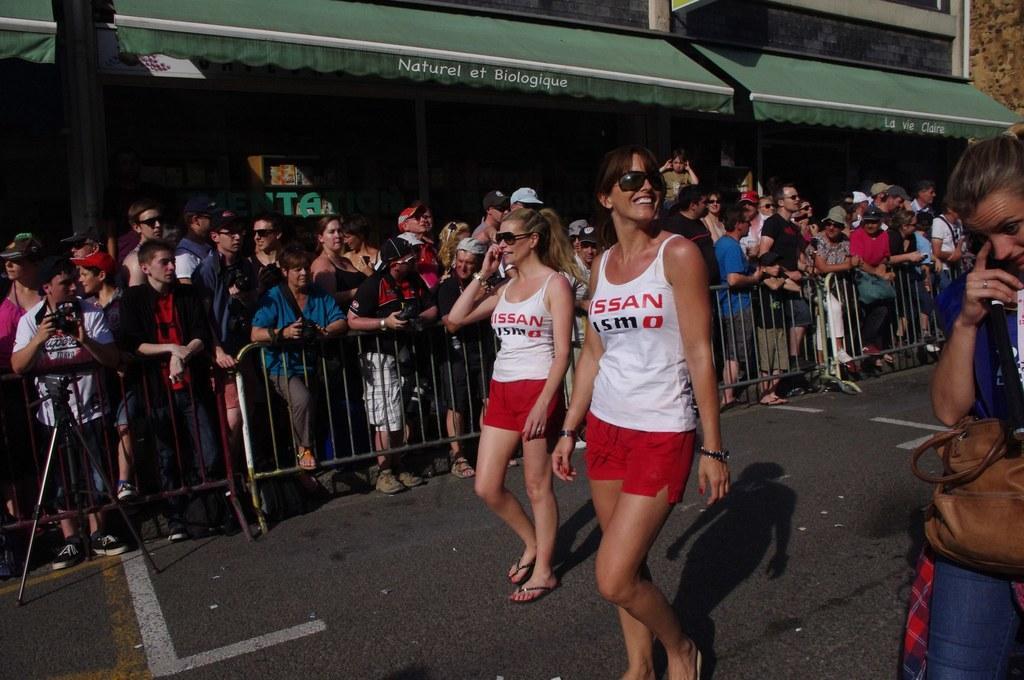Please provide a concise description of this image. This is the picture of a road. In this image there are two persons with white t-shirt walking on the road and smiling. At the back there are group of people standing behind the railing. On the left side of the image there is a person with white t-shirt is holding the camera. On the right side of the image there is a person standing and holding the back. At the back there is a building. At the bottom there is a road. 